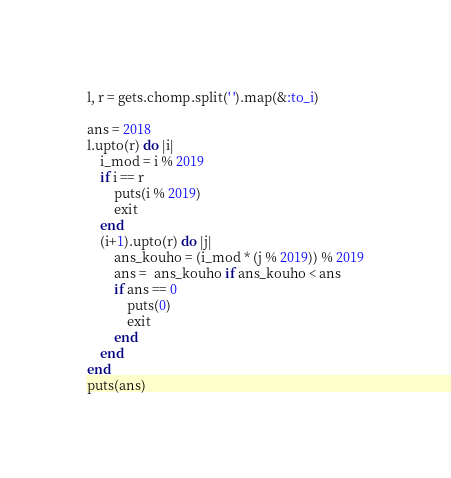Convert code to text. <code><loc_0><loc_0><loc_500><loc_500><_Ruby_>l, r = gets.chomp.split(' ').map(&:to_i)

ans = 2018
l.upto(r) do |i|
    i_mod = i % 2019
    if i == r
        puts(i % 2019)
        exit
    end
    (i+1).upto(r) do |j|
        ans_kouho = (i_mod * (j % 2019)) % 2019
        ans =  ans_kouho if ans_kouho < ans
        if ans == 0
            puts(0)
            exit
        end
    end
end
puts(ans)</code> 